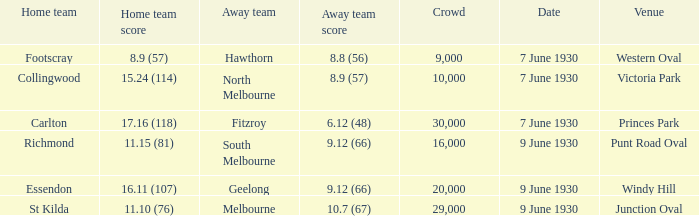What is the average crowd size when North Melbourne is the away team? 10000.0. 